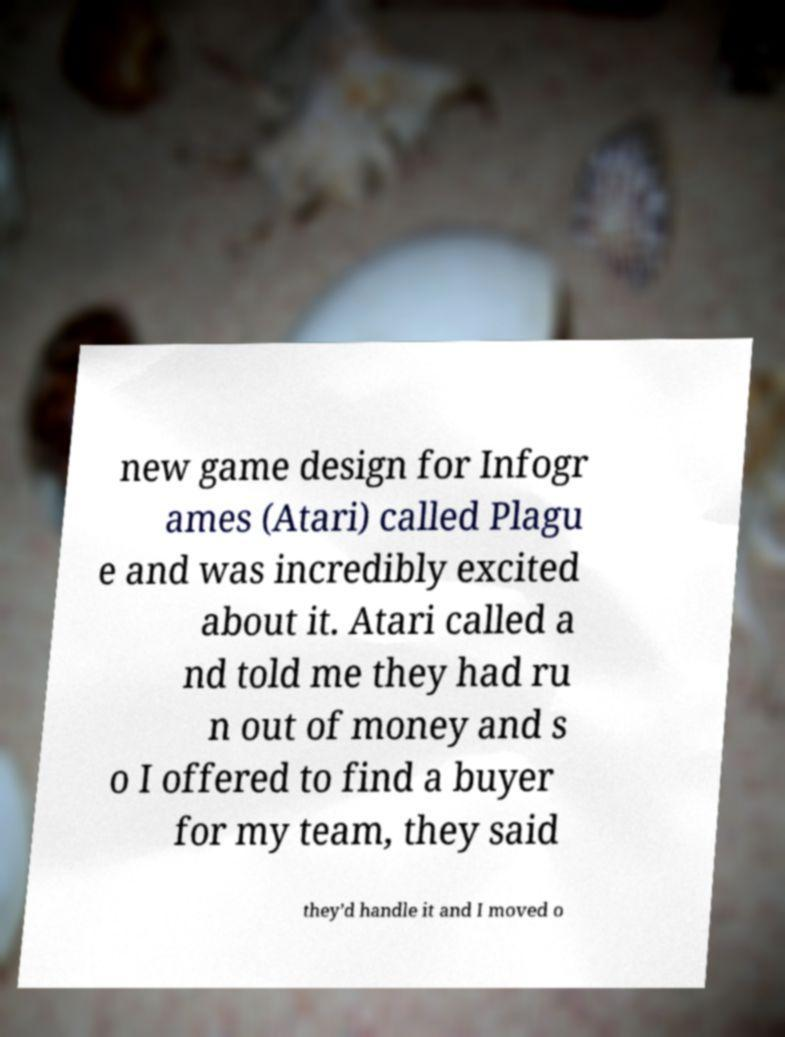What messages or text are displayed in this image? I need them in a readable, typed format. new game design for Infogr ames (Atari) called Plagu e and was incredibly excited about it. Atari called a nd told me they had ru n out of money and s o I offered to find a buyer for my team, they said they’d handle it and I moved o 